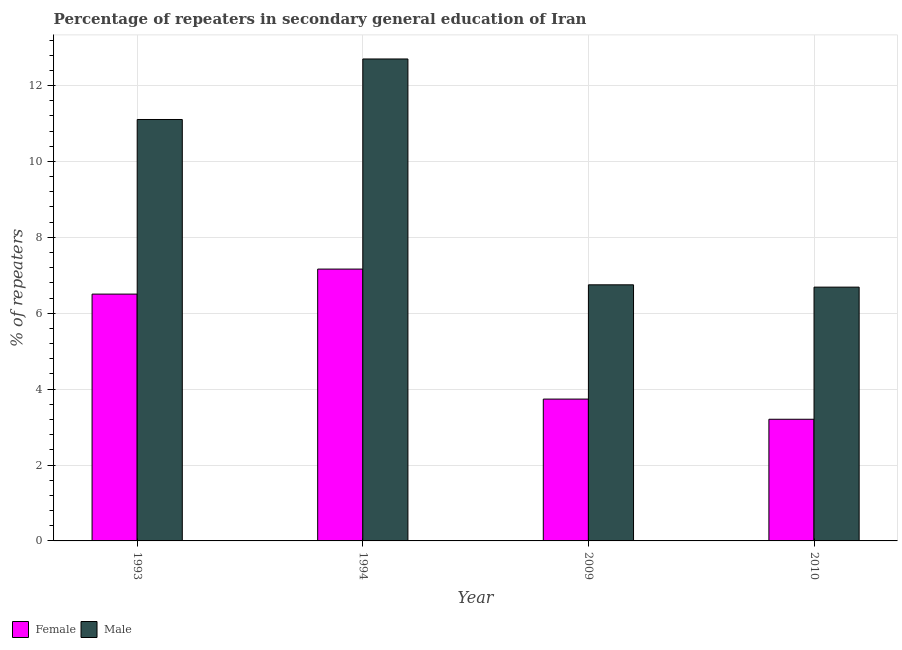How many groups of bars are there?
Provide a short and direct response. 4. Are the number of bars per tick equal to the number of legend labels?
Your answer should be very brief. Yes. How many bars are there on the 1st tick from the left?
Offer a terse response. 2. How many bars are there on the 4th tick from the right?
Offer a terse response. 2. In how many cases, is the number of bars for a given year not equal to the number of legend labels?
Make the answer very short. 0. What is the percentage of male repeaters in 2010?
Make the answer very short. 6.69. Across all years, what is the maximum percentage of male repeaters?
Provide a short and direct response. 12.7. Across all years, what is the minimum percentage of male repeaters?
Keep it short and to the point. 6.69. What is the total percentage of female repeaters in the graph?
Give a very brief answer. 20.61. What is the difference between the percentage of female repeaters in 1994 and that in 2009?
Offer a very short reply. 3.43. What is the difference between the percentage of female repeaters in 1994 and the percentage of male repeaters in 2010?
Your response must be concise. 3.96. What is the average percentage of male repeaters per year?
Your answer should be compact. 9.31. In the year 2010, what is the difference between the percentage of female repeaters and percentage of male repeaters?
Make the answer very short. 0. What is the ratio of the percentage of male repeaters in 2009 to that in 2010?
Offer a terse response. 1.01. Is the difference between the percentage of male repeaters in 1993 and 2010 greater than the difference between the percentage of female repeaters in 1993 and 2010?
Provide a short and direct response. No. What is the difference between the highest and the second highest percentage of male repeaters?
Make the answer very short. 1.59. What is the difference between the highest and the lowest percentage of male repeaters?
Offer a very short reply. 6.01. In how many years, is the percentage of male repeaters greater than the average percentage of male repeaters taken over all years?
Provide a succinct answer. 2. Is the sum of the percentage of female repeaters in 1993 and 1994 greater than the maximum percentage of male repeaters across all years?
Give a very brief answer. Yes. How many bars are there?
Provide a short and direct response. 8. Are all the bars in the graph horizontal?
Your response must be concise. No. How many years are there in the graph?
Your answer should be compact. 4. Are the values on the major ticks of Y-axis written in scientific E-notation?
Offer a terse response. No. Does the graph contain any zero values?
Keep it short and to the point. No. Does the graph contain grids?
Keep it short and to the point. Yes. Where does the legend appear in the graph?
Give a very brief answer. Bottom left. What is the title of the graph?
Your response must be concise. Percentage of repeaters in secondary general education of Iran. What is the label or title of the Y-axis?
Provide a short and direct response. % of repeaters. What is the % of repeaters in Female in 1993?
Give a very brief answer. 6.5. What is the % of repeaters in Male in 1993?
Make the answer very short. 11.11. What is the % of repeaters in Female in 1994?
Offer a terse response. 7.16. What is the % of repeaters of Male in 1994?
Give a very brief answer. 12.7. What is the % of repeaters of Female in 2009?
Offer a terse response. 3.74. What is the % of repeaters of Male in 2009?
Make the answer very short. 6.75. What is the % of repeaters in Female in 2010?
Keep it short and to the point. 3.21. What is the % of repeaters in Male in 2010?
Make the answer very short. 6.69. Across all years, what is the maximum % of repeaters of Female?
Offer a terse response. 7.16. Across all years, what is the maximum % of repeaters in Male?
Keep it short and to the point. 12.7. Across all years, what is the minimum % of repeaters of Female?
Provide a short and direct response. 3.21. Across all years, what is the minimum % of repeaters of Male?
Offer a terse response. 6.69. What is the total % of repeaters of Female in the graph?
Give a very brief answer. 20.61. What is the total % of repeaters of Male in the graph?
Provide a short and direct response. 37.24. What is the difference between the % of repeaters in Female in 1993 and that in 1994?
Your response must be concise. -0.66. What is the difference between the % of repeaters of Male in 1993 and that in 1994?
Make the answer very short. -1.59. What is the difference between the % of repeaters in Female in 1993 and that in 2009?
Provide a succinct answer. 2.77. What is the difference between the % of repeaters of Male in 1993 and that in 2009?
Provide a short and direct response. 4.36. What is the difference between the % of repeaters of Female in 1993 and that in 2010?
Make the answer very short. 3.3. What is the difference between the % of repeaters of Male in 1993 and that in 2010?
Your response must be concise. 4.42. What is the difference between the % of repeaters of Female in 1994 and that in 2009?
Offer a terse response. 3.43. What is the difference between the % of repeaters of Male in 1994 and that in 2009?
Ensure brevity in your answer.  5.95. What is the difference between the % of repeaters in Female in 1994 and that in 2010?
Make the answer very short. 3.96. What is the difference between the % of repeaters of Male in 1994 and that in 2010?
Offer a terse response. 6.01. What is the difference between the % of repeaters in Female in 2009 and that in 2010?
Keep it short and to the point. 0.53. What is the difference between the % of repeaters of Male in 2009 and that in 2010?
Your answer should be very brief. 0.06. What is the difference between the % of repeaters of Female in 1993 and the % of repeaters of Male in 1994?
Provide a succinct answer. -6.2. What is the difference between the % of repeaters in Female in 1993 and the % of repeaters in Male in 2009?
Your response must be concise. -0.24. What is the difference between the % of repeaters in Female in 1993 and the % of repeaters in Male in 2010?
Your response must be concise. -0.18. What is the difference between the % of repeaters of Female in 1994 and the % of repeaters of Male in 2009?
Your answer should be very brief. 0.41. What is the difference between the % of repeaters of Female in 1994 and the % of repeaters of Male in 2010?
Your answer should be very brief. 0.48. What is the difference between the % of repeaters of Female in 2009 and the % of repeaters of Male in 2010?
Your answer should be very brief. -2.95. What is the average % of repeaters of Female per year?
Your response must be concise. 5.15. What is the average % of repeaters of Male per year?
Offer a terse response. 9.31. In the year 1993, what is the difference between the % of repeaters of Female and % of repeaters of Male?
Provide a succinct answer. -4.6. In the year 1994, what is the difference between the % of repeaters of Female and % of repeaters of Male?
Provide a succinct answer. -5.54. In the year 2009, what is the difference between the % of repeaters in Female and % of repeaters in Male?
Offer a terse response. -3.01. In the year 2010, what is the difference between the % of repeaters in Female and % of repeaters in Male?
Your response must be concise. -3.48. What is the ratio of the % of repeaters in Female in 1993 to that in 1994?
Provide a short and direct response. 0.91. What is the ratio of the % of repeaters in Male in 1993 to that in 1994?
Offer a terse response. 0.87. What is the ratio of the % of repeaters of Female in 1993 to that in 2009?
Your answer should be compact. 1.74. What is the ratio of the % of repeaters in Male in 1993 to that in 2009?
Your answer should be compact. 1.65. What is the ratio of the % of repeaters of Female in 1993 to that in 2010?
Your response must be concise. 2.03. What is the ratio of the % of repeaters of Male in 1993 to that in 2010?
Your answer should be very brief. 1.66. What is the ratio of the % of repeaters of Female in 1994 to that in 2009?
Offer a terse response. 1.92. What is the ratio of the % of repeaters in Male in 1994 to that in 2009?
Ensure brevity in your answer.  1.88. What is the ratio of the % of repeaters in Female in 1994 to that in 2010?
Your answer should be compact. 2.23. What is the ratio of the % of repeaters in Male in 1994 to that in 2010?
Keep it short and to the point. 1.9. What is the ratio of the % of repeaters of Female in 2009 to that in 2010?
Give a very brief answer. 1.17. What is the ratio of the % of repeaters of Male in 2009 to that in 2010?
Your response must be concise. 1.01. What is the difference between the highest and the second highest % of repeaters of Female?
Provide a succinct answer. 0.66. What is the difference between the highest and the second highest % of repeaters in Male?
Provide a short and direct response. 1.59. What is the difference between the highest and the lowest % of repeaters of Female?
Ensure brevity in your answer.  3.96. What is the difference between the highest and the lowest % of repeaters in Male?
Provide a succinct answer. 6.01. 